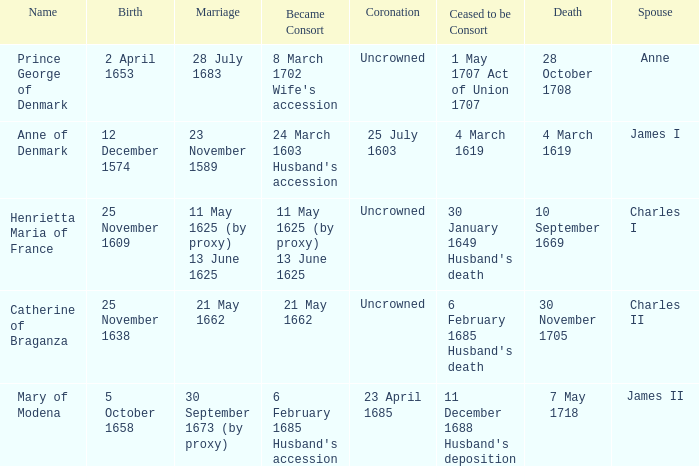On what date did James II take a consort? 6 February 1685 Husband's accession. 